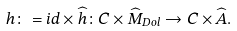<formula> <loc_0><loc_0><loc_500><loc_500>h \colon = i d \times \widehat { h } \colon C \times \widehat { M } _ { D o l } \to C \times \widehat { A } .</formula> 